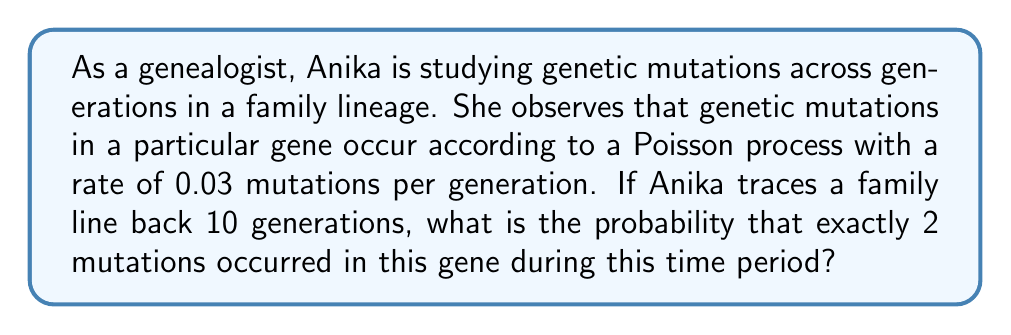Provide a solution to this math problem. To solve this problem, we'll use the Poisson distribution, which models the number of events occurring in a fixed interval when these events happen at a constant average rate. Let's approach this step-by-step:

1) The Poisson distribution is given by the formula:

   $$P(X = k) = \frac{e^{-\lambda} \lambda^k}{k!}$$

   where:
   - $\lambda$ is the average number of events in the interval
   - $k$ is the number of events we're interested in
   - $e$ is Euler's number (approximately 2.71828)

2) In this case:
   - The rate is 0.03 mutations per generation
   - We're looking at 10 generations
   - We want the probability of exactly 2 mutations

3) First, calculate $\lambda$:
   $$\lambda = 0.03 \text{ mutations/generation} \times 10 \text{ generations} = 0.3$$

4) Now, we can plug into the Poisson formula:
   $$P(X = 2) = \frac{e^{-0.3} 0.3^2}{2!}$$

5) Let's calculate this step-by-step:
   - $e^{-0.3} \approx 0.7408$
   - $0.3^2 = 0.09$
   - $2! = 2 \times 1 = 2$

6) Putting it all together:
   $$P(X = 2) = \frac{0.7408 \times 0.09}{2} = 0.03334$$

7) Therefore, the probability is approximately 0.03334 or about 3.33%.
Answer: 0.03334 (or 3.33%) 